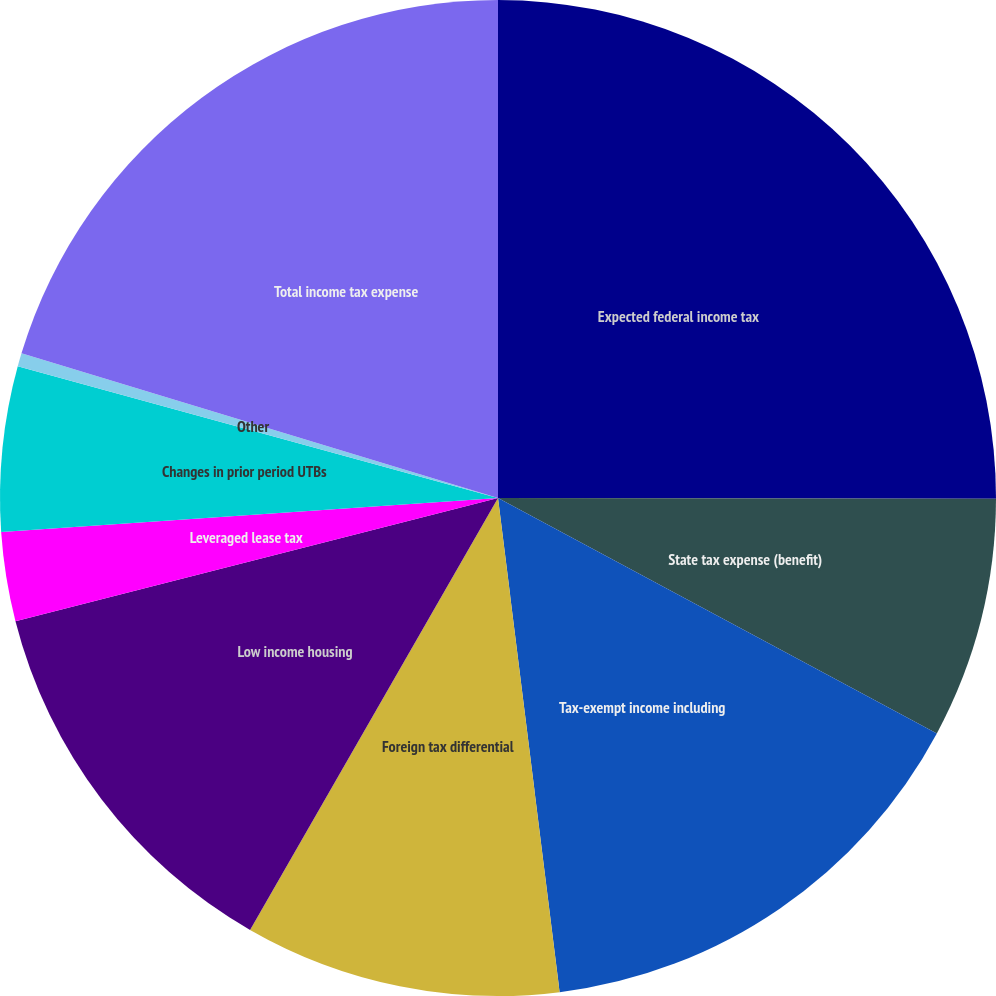<chart> <loc_0><loc_0><loc_500><loc_500><pie_chart><fcel>Expected federal income tax<fcel>State tax expense (benefit)<fcel>Tax-exempt income including<fcel>Foreign tax differential<fcel>Low income housing<fcel>Leveraged lease tax<fcel>Changes in prior period UTBs<fcel>Other<fcel>Total income tax expense<nl><fcel>25.03%<fcel>7.81%<fcel>15.19%<fcel>10.27%<fcel>12.73%<fcel>2.89%<fcel>5.35%<fcel>0.43%<fcel>20.31%<nl></chart> 